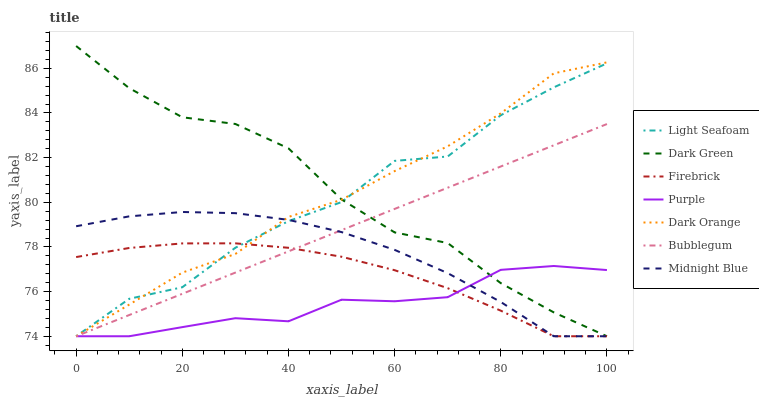Does Purple have the minimum area under the curve?
Answer yes or no. Yes. Does Dark Green have the maximum area under the curve?
Answer yes or no. Yes. Does Midnight Blue have the minimum area under the curve?
Answer yes or no. No. Does Midnight Blue have the maximum area under the curve?
Answer yes or no. No. Is Bubblegum the smoothest?
Answer yes or no. Yes. Is Light Seafoam the roughest?
Answer yes or no. Yes. Is Midnight Blue the smoothest?
Answer yes or no. No. Is Midnight Blue the roughest?
Answer yes or no. No. Does Dark Green have the highest value?
Answer yes or no. Yes. Does Midnight Blue have the highest value?
Answer yes or no. No. Does Bubblegum intersect Firebrick?
Answer yes or no. Yes. Is Bubblegum less than Firebrick?
Answer yes or no. No. Is Bubblegum greater than Firebrick?
Answer yes or no. No. 